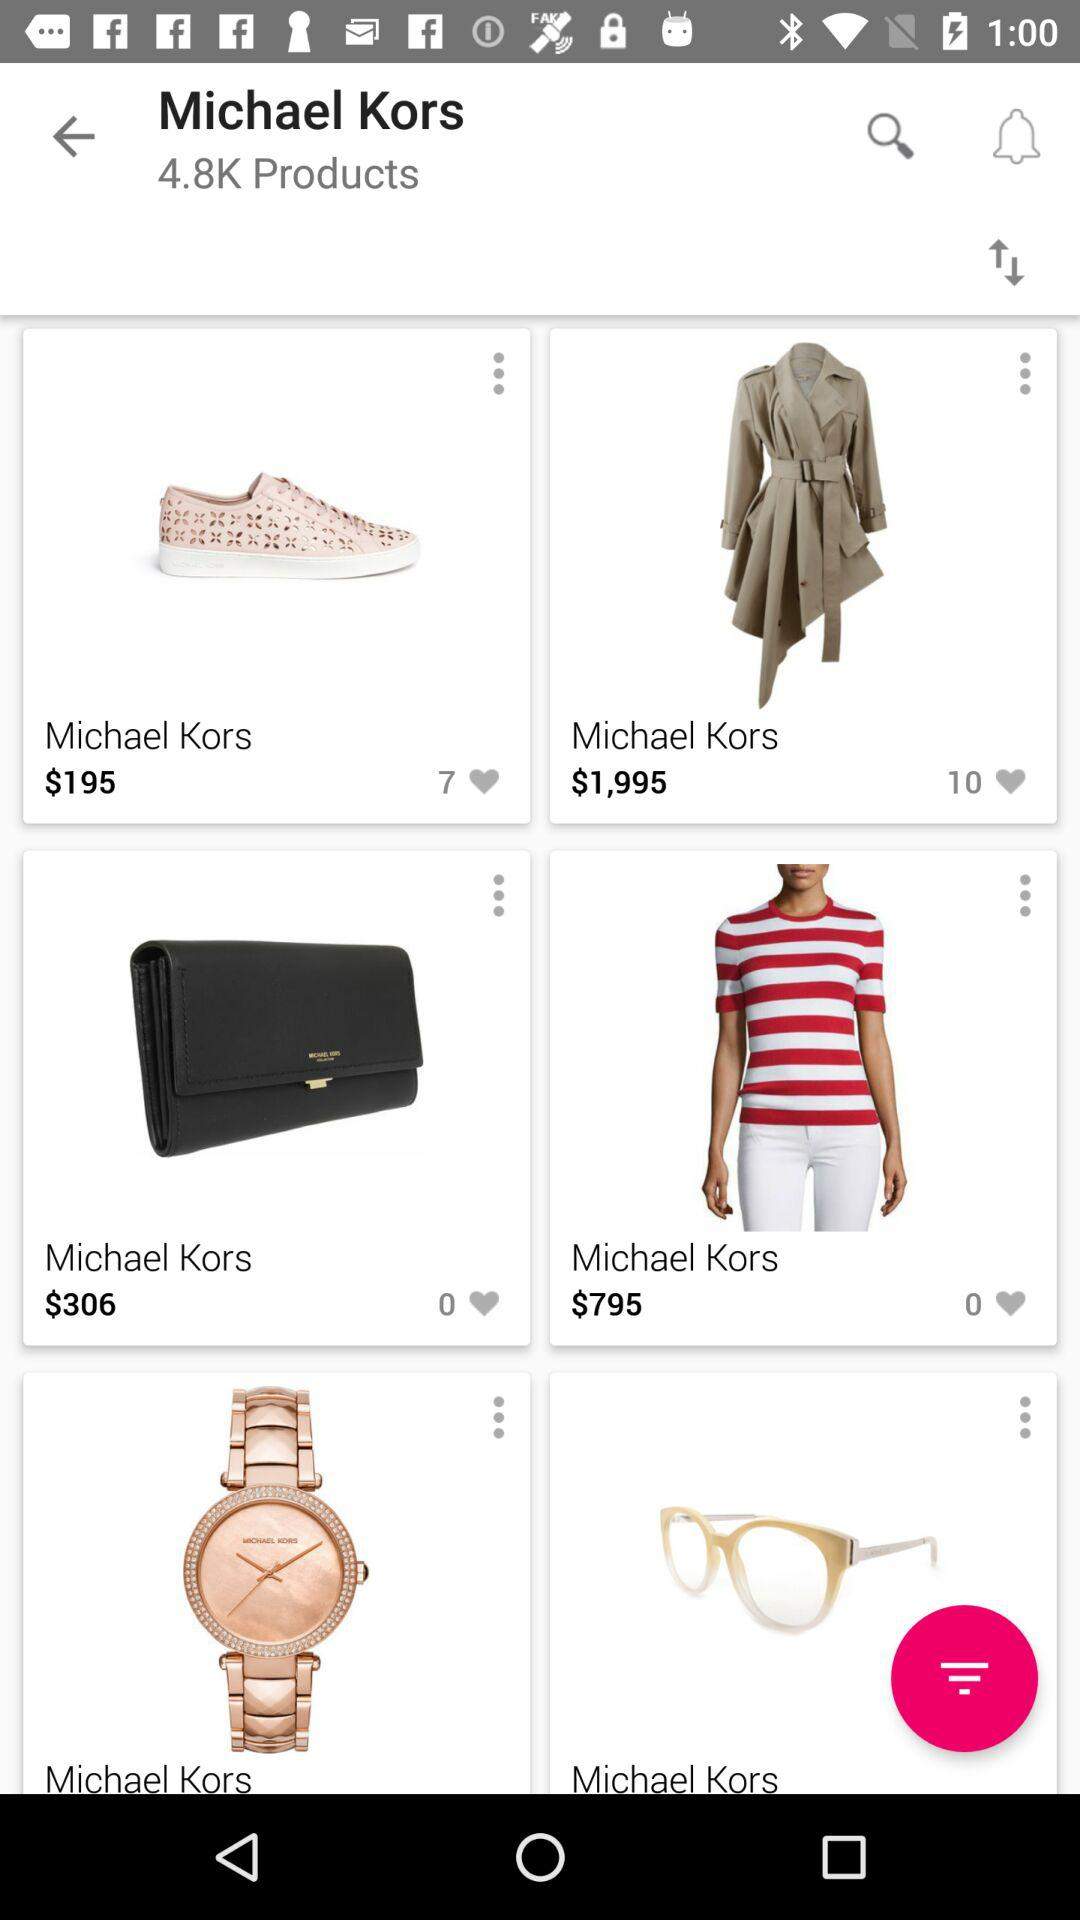How many have liked shoes?
When the provided information is insufficient, respond with <no answer>. <no answer> 